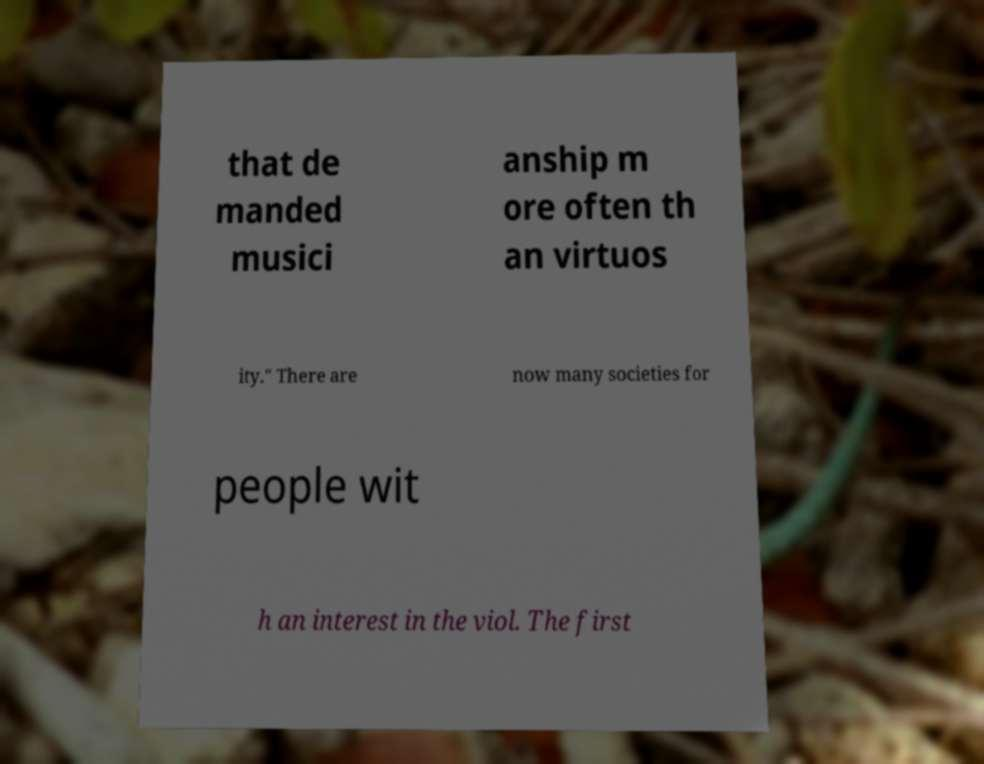Could you extract and type out the text from this image? that de manded musici anship m ore often th an virtuos ity." There are now many societies for people wit h an interest in the viol. The first 